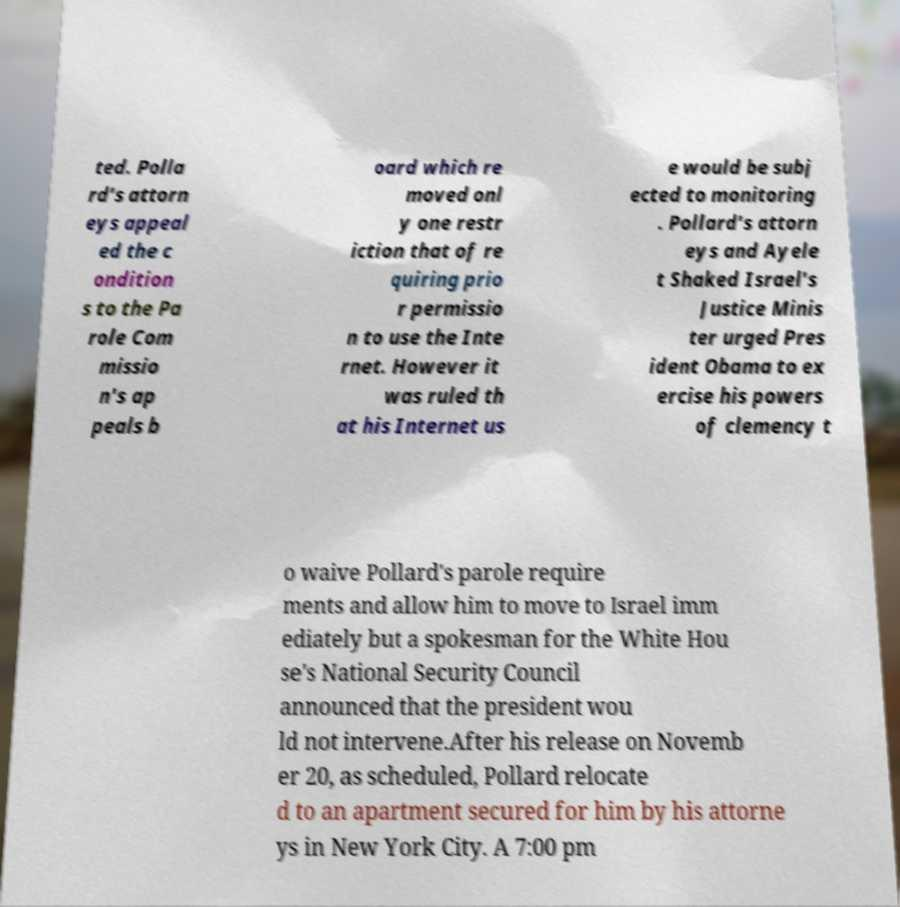What messages or text are displayed in this image? I need them in a readable, typed format. ted. Polla rd's attorn eys appeal ed the c ondition s to the Pa role Com missio n's ap peals b oard which re moved onl y one restr iction that of re quiring prio r permissio n to use the Inte rnet. However it was ruled th at his Internet us e would be subj ected to monitoring . Pollard's attorn eys and Ayele t Shaked Israel's Justice Minis ter urged Pres ident Obama to ex ercise his powers of clemency t o waive Pollard's parole require ments and allow him to move to Israel imm ediately but a spokesman for the White Hou se's National Security Council announced that the president wou ld not intervene.After his release on Novemb er 20, as scheduled, Pollard relocate d to an apartment secured for him by his attorne ys in New York City. A 7:00 pm 